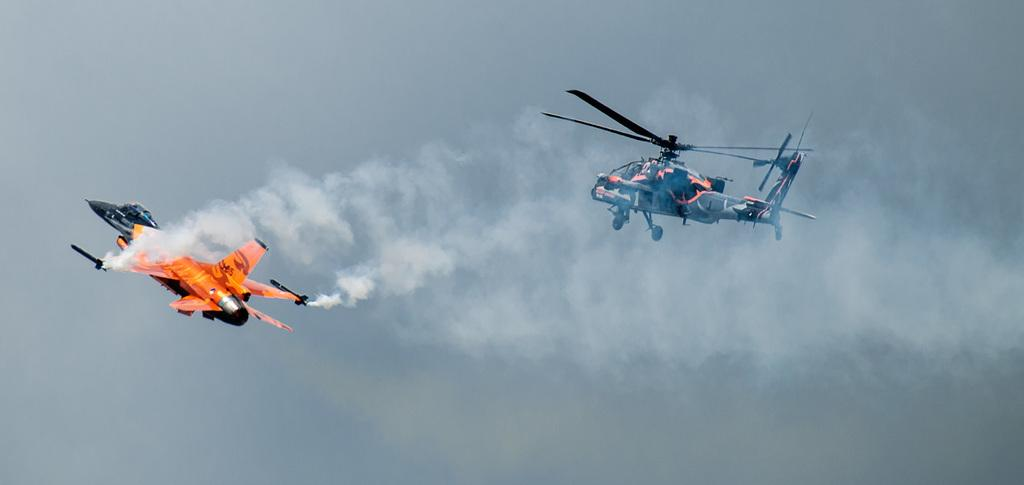What is the main subject of the image? The main subject of the image is two aircraft. What colors are the aircraft? The aircraft are in orange, black, and blue colors. Where are the aircraft located in the image? The aircraft are in the air. What else can be seen in the image besides the aircraft? There is smoke visible in the image, and the sky is also visible. What type of food is being served with a spoon in the image? There is no food or spoon present in the image; it features two aircraft in the air. Is there an umbrella visible in the image? No, there is no umbrella present in the image. 